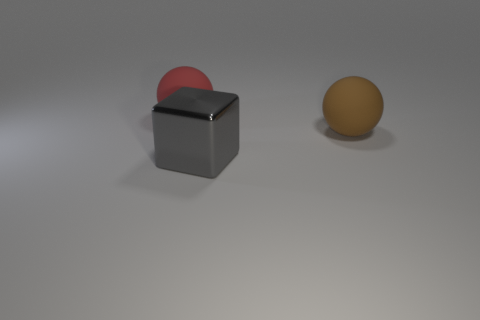Is there anything else that has the same material as the large cube?
Offer a terse response. No. What color is the large rubber sphere behind the sphere that is right of the gray metallic block?
Your answer should be compact. Red. Are there fewer gray metallic blocks that are to the right of the large brown rubber thing than big red things left of the shiny object?
Give a very brief answer. Yes. How many red cubes are made of the same material as the brown object?
Provide a short and direct response. 0. There is a matte ball to the right of the rubber ball to the left of the big gray object; is there a large gray thing in front of it?
Offer a very short reply. Yes. There is a big red object that is the same material as the brown thing; what shape is it?
Offer a very short reply. Sphere. Are there more gray cubes than gray matte spheres?
Ensure brevity in your answer.  Yes. There is a large red rubber object; does it have the same shape as the object that is in front of the brown thing?
Make the answer very short. No. What material is the gray thing?
Offer a terse response. Metal. The large matte sphere right of the matte sphere that is on the left side of the large matte ball on the right side of the shiny cube is what color?
Keep it short and to the point. Brown. 